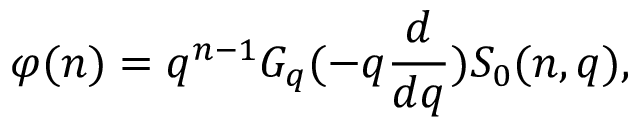Convert formula to latex. <formula><loc_0><loc_0><loc_500><loc_500>\varphi ( n ) = q ^ { n - 1 } G _ { q } ( - q \frac { d } { d q } ) S _ { 0 } ( n , q ) ,</formula> 